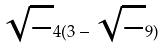<formula> <loc_0><loc_0><loc_500><loc_500>\sqrt { - } 4 ( 3 - \sqrt { - } 9 )</formula> 